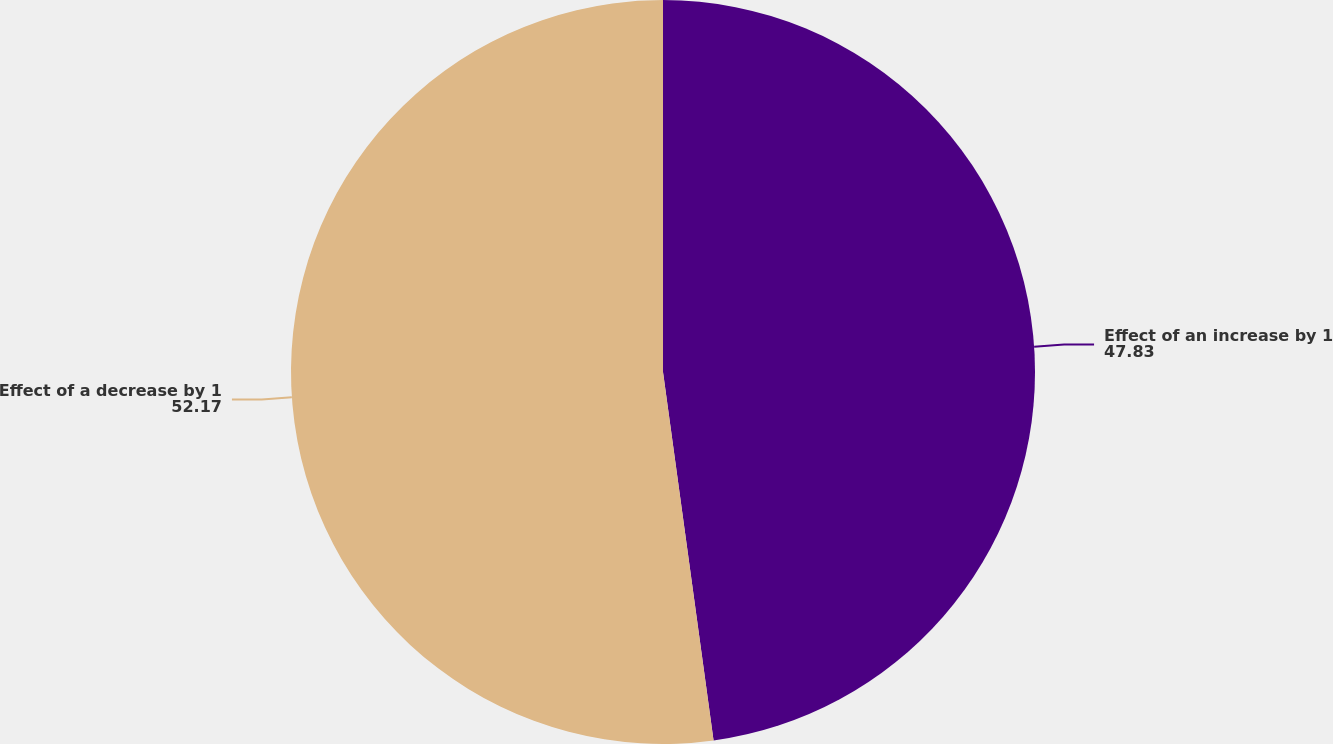<chart> <loc_0><loc_0><loc_500><loc_500><pie_chart><fcel>Effect of an increase by 1<fcel>Effect of a decrease by 1<nl><fcel>47.83%<fcel>52.17%<nl></chart> 